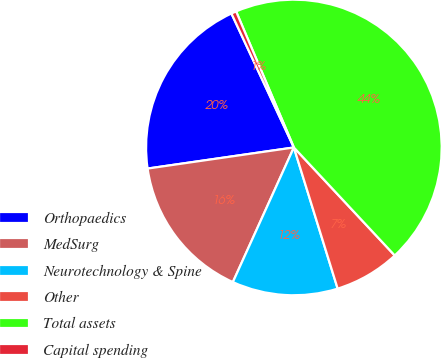<chart> <loc_0><loc_0><loc_500><loc_500><pie_chart><fcel>Orthopaedics<fcel>MedSurg<fcel>Neurotechnology & Spine<fcel>Other<fcel>Total assets<fcel>Capital spending<nl><fcel>20.34%<fcel>15.95%<fcel>11.56%<fcel>7.17%<fcel>44.44%<fcel>0.55%<nl></chart> 